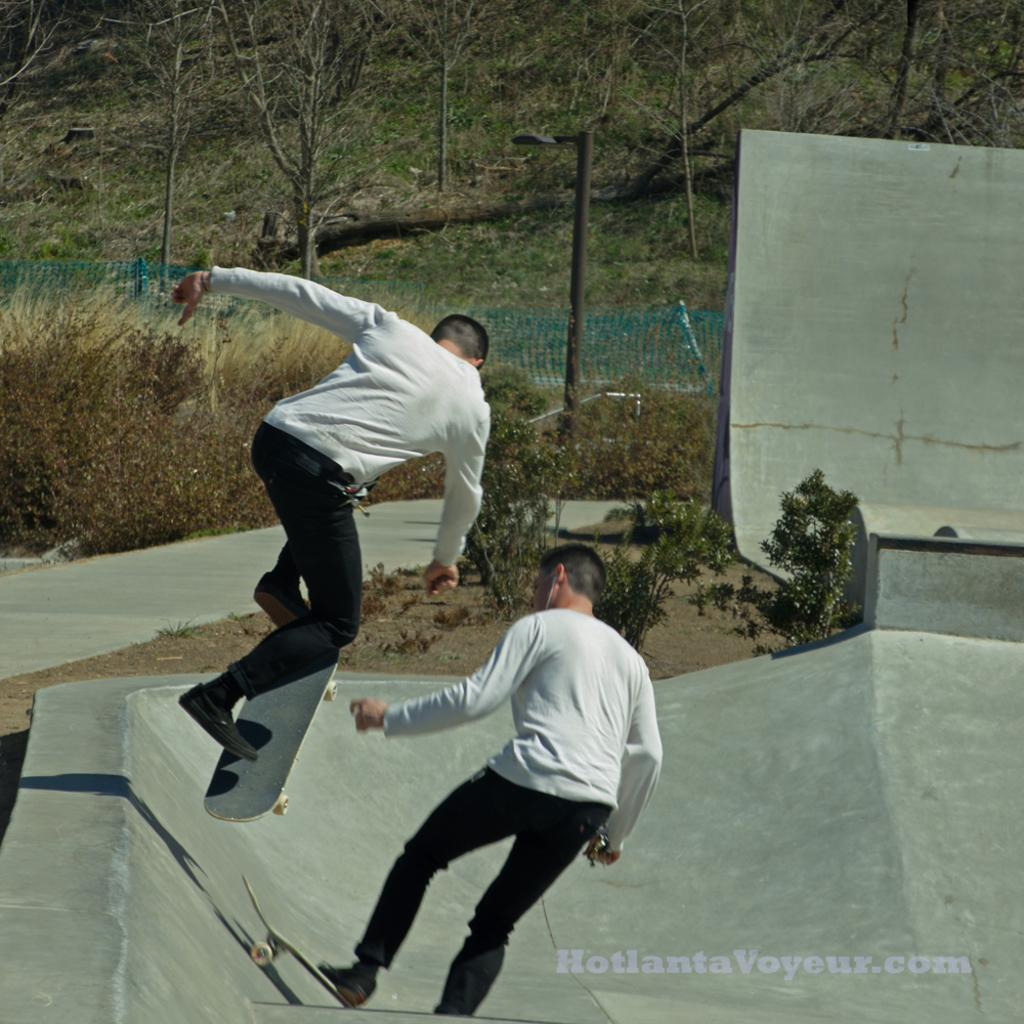What are the two men in the image doing? The two men are standing on skateboards in the image. Can you describe the action of one of the men? One man is in the air in the image. What can be seen beneath the men's feet? There is a path visible in the image. What is separating the path from the background? There is a fence in the image. What type of vegetation is visible in the background? Trees are present in the background of the image. Where is the kettle placed in the image? There is no kettle present in the image. What type of pets can be seen playing with the men on skateboards? There are no pets visible in the image; it features two men on skateboards and a man in the air. 